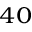<formula> <loc_0><loc_0><loc_500><loc_500>{ } ^ { 4 0 }</formula> 